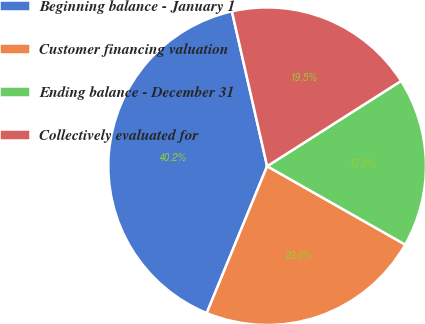<chart> <loc_0><loc_0><loc_500><loc_500><pie_chart><fcel>Beginning balance - January 1<fcel>Customer financing valuation<fcel>Ending balance - December 31<fcel>Collectively evaluated for<nl><fcel>40.23%<fcel>22.99%<fcel>17.24%<fcel>19.54%<nl></chart> 